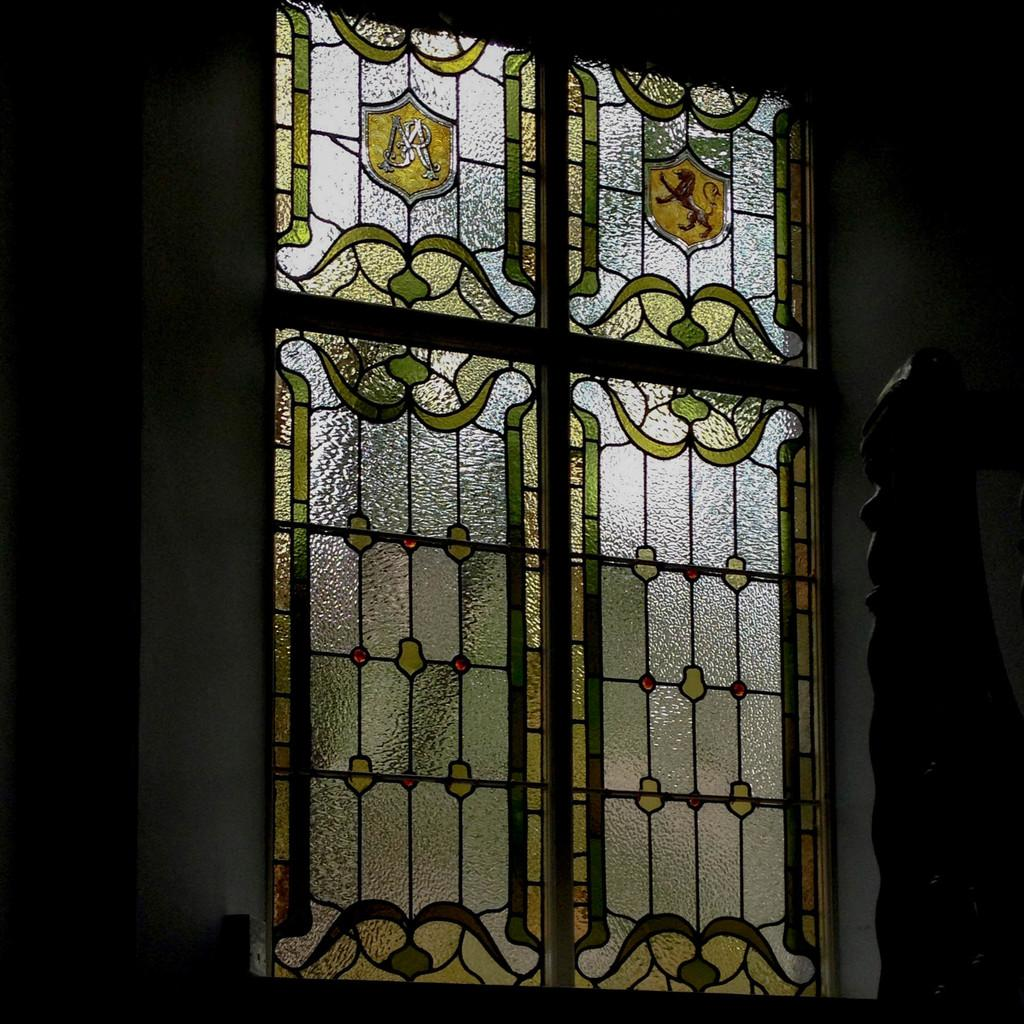What is located in the middle of the image? There is a glass window in the middle of the image. What can be seen in the background of the image? There is a wall in the background of the image. What is the color of the wall? The wall has a black color. How many pizzas are being delivered to the wall in the image? There are no pizzas or delivery mentioned in the image; it only features a glass window and a black wall. 